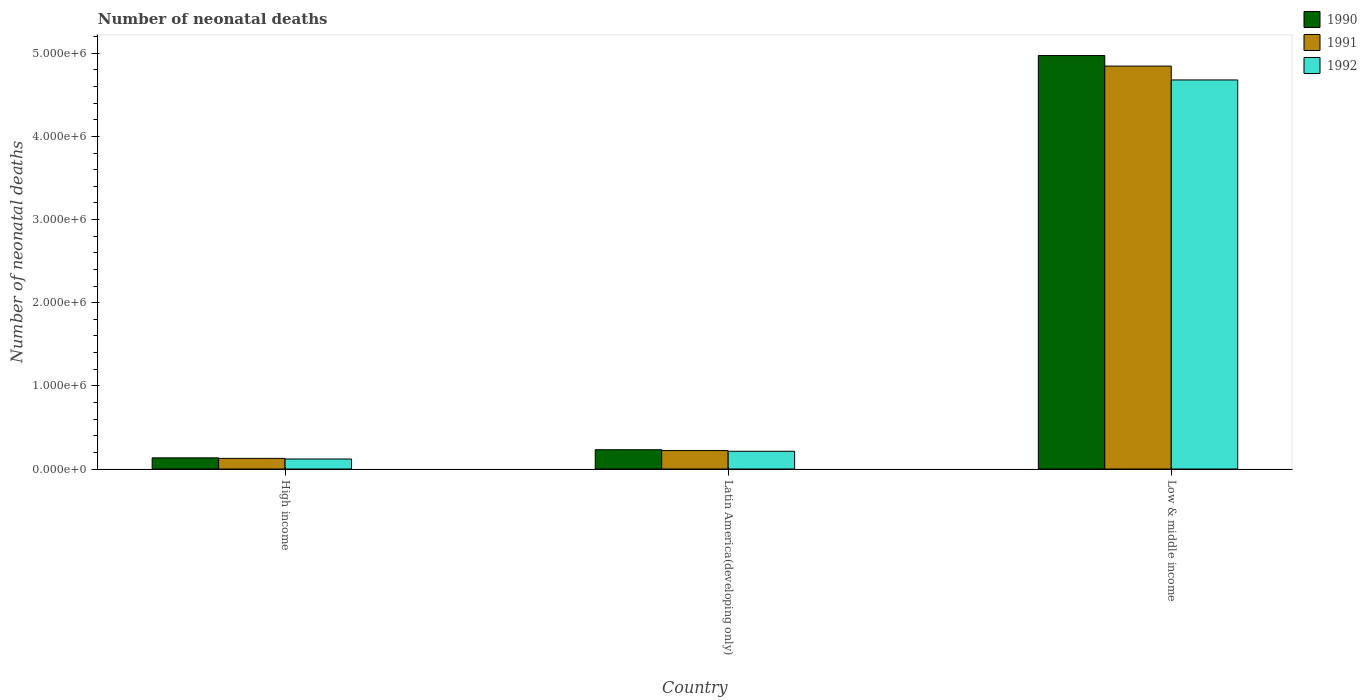Are the number of bars per tick equal to the number of legend labels?
Your answer should be compact. Yes. Are the number of bars on each tick of the X-axis equal?
Provide a short and direct response. Yes. How many bars are there on the 1st tick from the left?
Your answer should be compact. 3. How many bars are there on the 2nd tick from the right?
Make the answer very short. 3. What is the label of the 3rd group of bars from the left?
Your response must be concise. Low & middle income. What is the number of neonatal deaths in in 1992 in Low & middle income?
Ensure brevity in your answer.  4.68e+06. Across all countries, what is the maximum number of neonatal deaths in in 1991?
Provide a short and direct response. 4.85e+06. Across all countries, what is the minimum number of neonatal deaths in in 1992?
Your response must be concise. 1.20e+05. In which country was the number of neonatal deaths in in 1990 minimum?
Make the answer very short. High income. What is the total number of neonatal deaths in in 1991 in the graph?
Ensure brevity in your answer.  5.19e+06. What is the difference between the number of neonatal deaths in in 1992 in Latin America(developing only) and that in Low & middle income?
Offer a very short reply. -4.47e+06. What is the difference between the number of neonatal deaths in in 1990 in High income and the number of neonatal deaths in in 1991 in Low & middle income?
Offer a very short reply. -4.71e+06. What is the average number of neonatal deaths in in 1992 per country?
Provide a short and direct response. 1.67e+06. What is the difference between the number of neonatal deaths in of/in 1992 and number of neonatal deaths in of/in 1990 in Low & middle income?
Provide a short and direct response. -2.93e+05. What is the ratio of the number of neonatal deaths in in 1990 in High income to that in Low & middle income?
Your answer should be very brief. 0.03. Is the number of neonatal deaths in in 1991 in Latin America(developing only) less than that in Low & middle income?
Ensure brevity in your answer.  Yes. Is the difference between the number of neonatal deaths in in 1992 in High income and Low & middle income greater than the difference between the number of neonatal deaths in in 1990 in High income and Low & middle income?
Offer a terse response. Yes. What is the difference between the highest and the second highest number of neonatal deaths in in 1991?
Provide a succinct answer. -4.62e+06. What is the difference between the highest and the lowest number of neonatal deaths in in 1990?
Provide a succinct answer. 4.84e+06. In how many countries, is the number of neonatal deaths in in 1991 greater than the average number of neonatal deaths in in 1991 taken over all countries?
Provide a succinct answer. 1. Is the sum of the number of neonatal deaths in in 1990 in High income and Low & middle income greater than the maximum number of neonatal deaths in in 1992 across all countries?
Give a very brief answer. Yes. Is it the case that in every country, the sum of the number of neonatal deaths in in 1991 and number of neonatal deaths in in 1992 is greater than the number of neonatal deaths in in 1990?
Make the answer very short. Yes. Are all the bars in the graph horizontal?
Provide a succinct answer. No. Are the values on the major ticks of Y-axis written in scientific E-notation?
Offer a terse response. Yes. Does the graph contain any zero values?
Make the answer very short. No. Where does the legend appear in the graph?
Provide a succinct answer. Top right. How are the legend labels stacked?
Your answer should be compact. Vertical. What is the title of the graph?
Your response must be concise. Number of neonatal deaths. Does "2009" appear as one of the legend labels in the graph?
Offer a terse response. No. What is the label or title of the Y-axis?
Ensure brevity in your answer.  Number of neonatal deaths. What is the Number of neonatal deaths in 1990 in High income?
Your answer should be very brief. 1.34e+05. What is the Number of neonatal deaths of 1991 in High income?
Ensure brevity in your answer.  1.28e+05. What is the Number of neonatal deaths of 1992 in High income?
Provide a succinct answer. 1.20e+05. What is the Number of neonatal deaths of 1990 in Latin America(developing only)?
Make the answer very short. 2.32e+05. What is the Number of neonatal deaths in 1991 in Latin America(developing only)?
Offer a very short reply. 2.22e+05. What is the Number of neonatal deaths of 1992 in Latin America(developing only)?
Make the answer very short. 2.13e+05. What is the Number of neonatal deaths in 1990 in Low & middle income?
Offer a terse response. 4.97e+06. What is the Number of neonatal deaths of 1991 in Low & middle income?
Your response must be concise. 4.85e+06. What is the Number of neonatal deaths of 1992 in Low & middle income?
Your answer should be compact. 4.68e+06. Across all countries, what is the maximum Number of neonatal deaths of 1990?
Your answer should be very brief. 4.97e+06. Across all countries, what is the maximum Number of neonatal deaths of 1991?
Give a very brief answer. 4.85e+06. Across all countries, what is the maximum Number of neonatal deaths in 1992?
Give a very brief answer. 4.68e+06. Across all countries, what is the minimum Number of neonatal deaths in 1990?
Make the answer very short. 1.34e+05. Across all countries, what is the minimum Number of neonatal deaths of 1991?
Ensure brevity in your answer.  1.28e+05. Across all countries, what is the minimum Number of neonatal deaths in 1992?
Your answer should be very brief. 1.20e+05. What is the total Number of neonatal deaths in 1990 in the graph?
Make the answer very short. 5.34e+06. What is the total Number of neonatal deaths of 1991 in the graph?
Your answer should be very brief. 5.19e+06. What is the total Number of neonatal deaths in 1992 in the graph?
Keep it short and to the point. 5.01e+06. What is the difference between the Number of neonatal deaths in 1990 in High income and that in Latin America(developing only)?
Make the answer very short. -9.74e+04. What is the difference between the Number of neonatal deaths of 1991 in High income and that in Latin America(developing only)?
Your answer should be compact. -9.40e+04. What is the difference between the Number of neonatal deaths of 1992 in High income and that in Latin America(developing only)?
Provide a succinct answer. -9.29e+04. What is the difference between the Number of neonatal deaths in 1990 in High income and that in Low & middle income?
Make the answer very short. -4.84e+06. What is the difference between the Number of neonatal deaths of 1991 in High income and that in Low & middle income?
Your response must be concise. -4.72e+06. What is the difference between the Number of neonatal deaths of 1992 in High income and that in Low & middle income?
Offer a very short reply. -4.56e+06. What is the difference between the Number of neonatal deaths of 1990 in Latin America(developing only) and that in Low & middle income?
Give a very brief answer. -4.74e+06. What is the difference between the Number of neonatal deaths of 1991 in Latin America(developing only) and that in Low & middle income?
Offer a very short reply. -4.62e+06. What is the difference between the Number of neonatal deaths of 1992 in Latin America(developing only) and that in Low & middle income?
Your answer should be compact. -4.47e+06. What is the difference between the Number of neonatal deaths of 1990 in High income and the Number of neonatal deaths of 1991 in Latin America(developing only)?
Your answer should be compact. -8.76e+04. What is the difference between the Number of neonatal deaths of 1990 in High income and the Number of neonatal deaths of 1992 in Latin America(developing only)?
Provide a succinct answer. -7.90e+04. What is the difference between the Number of neonatal deaths of 1991 in High income and the Number of neonatal deaths of 1992 in Latin America(developing only)?
Offer a terse response. -8.55e+04. What is the difference between the Number of neonatal deaths of 1990 in High income and the Number of neonatal deaths of 1991 in Low & middle income?
Provide a short and direct response. -4.71e+06. What is the difference between the Number of neonatal deaths in 1990 in High income and the Number of neonatal deaths in 1992 in Low & middle income?
Your answer should be compact. -4.54e+06. What is the difference between the Number of neonatal deaths of 1991 in High income and the Number of neonatal deaths of 1992 in Low & middle income?
Your response must be concise. -4.55e+06. What is the difference between the Number of neonatal deaths in 1990 in Latin America(developing only) and the Number of neonatal deaths in 1991 in Low & middle income?
Your answer should be compact. -4.61e+06. What is the difference between the Number of neonatal deaths in 1990 in Latin America(developing only) and the Number of neonatal deaths in 1992 in Low & middle income?
Keep it short and to the point. -4.45e+06. What is the difference between the Number of neonatal deaths of 1991 in Latin America(developing only) and the Number of neonatal deaths of 1992 in Low & middle income?
Provide a short and direct response. -4.46e+06. What is the average Number of neonatal deaths in 1990 per country?
Your answer should be compact. 1.78e+06. What is the average Number of neonatal deaths in 1991 per country?
Provide a short and direct response. 1.73e+06. What is the average Number of neonatal deaths in 1992 per country?
Offer a terse response. 1.67e+06. What is the difference between the Number of neonatal deaths of 1990 and Number of neonatal deaths of 1991 in High income?
Ensure brevity in your answer.  6492. What is the difference between the Number of neonatal deaths in 1990 and Number of neonatal deaths in 1992 in High income?
Offer a terse response. 1.39e+04. What is the difference between the Number of neonatal deaths in 1991 and Number of neonatal deaths in 1992 in High income?
Your answer should be compact. 7395. What is the difference between the Number of neonatal deaths of 1990 and Number of neonatal deaths of 1991 in Latin America(developing only)?
Your answer should be very brief. 9854. What is the difference between the Number of neonatal deaths in 1990 and Number of neonatal deaths in 1992 in Latin America(developing only)?
Your answer should be very brief. 1.84e+04. What is the difference between the Number of neonatal deaths in 1991 and Number of neonatal deaths in 1992 in Latin America(developing only)?
Ensure brevity in your answer.  8559. What is the difference between the Number of neonatal deaths of 1990 and Number of neonatal deaths of 1991 in Low & middle income?
Provide a succinct answer. 1.27e+05. What is the difference between the Number of neonatal deaths of 1990 and Number of neonatal deaths of 1992 in Low & middle income?
Your answer should be very brief. 2.93e+05. What is the difference between the Number of neonatal deaths of 1991 and Number of neonatal deaths of 1992 in Low & middle income?
Provide a succinct answer. 1.67e+05. What is the ratio of the Number of neonatal deaths of 1990 in High income to that in Latin America(developing only)?
Provide a succinct answer. 0.58. What is the ratio of the Number of neonatal deaths of 1991 in High income to that in Latin America(developing only)?
Your response must be concise. 0.58. What is the ratio of the Number of neonatal deaths in 1992 in High income to that in Latin America(developing only)?
Give a very brief answer. 0.56. What is the ratio of the Number of neonatal deaths of 1990 in High income to that in Low & middle income?
Your response must be concise. 0.03. What is the ratio of the Number of neonatal deaths in 1991 in High income to that in Low & middle income?
Offer a very short reply. 0.03. What is the ratio of the Number of neonatal deaths of 1992 in High income to that in Low & middle income?
Ensure brevity in your answer.  0.03. What is the ratio of the Number of neonatal deaths in 1990 in Latin America(developing only) to that in Low & middle income?
Ensure brevity in your answer.  0.05. What is the ratio of the Number of neonatal deaths in 1991 in Latin America(developing only) to that in Low & middle income?
Your answer should be compact. 0.05. What is the ratio of the Number of neonatal deaths in 1992 in Latin America(developing only) to that in Low & middle income?
Provide a short and direct response. 0.05. What is the difference between the highest and the second highest Number of neonatal deaths in 1990?
Provide a short and direct response. 4.74e+06. What is the difference between the highest and the second highest Number of neonatal deaths in 1991?
Give a very brief answer. 4.62e+06. What is the difference between the highest and the second highest Number of neonatal deaths of 1992?
Offer a very short reply. 4.47e+06. What is the difference between the highest and the lowest Number of neonatal deaths of 1990?
Your answer should be very brief. 4.84e+06. What is the difference between the highest and the lowest Number of neonatal deaths of 1991?
Your response must be concise. 4.72e+06. What is the difference between the highest and the lowest Number of neonatal deaths of 1992?
Ensure brevity in your answer.  4.56e+06. 